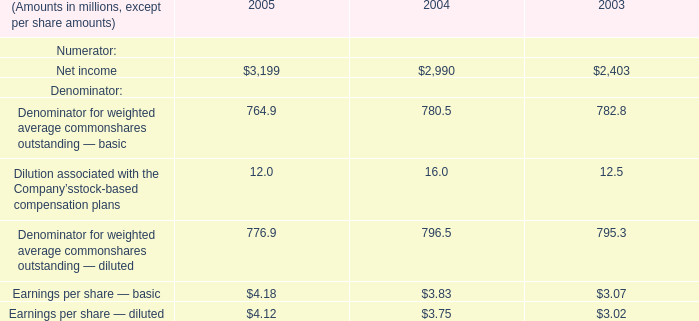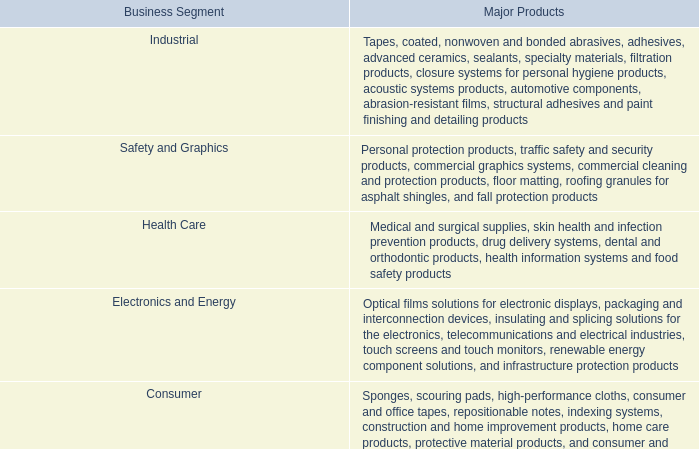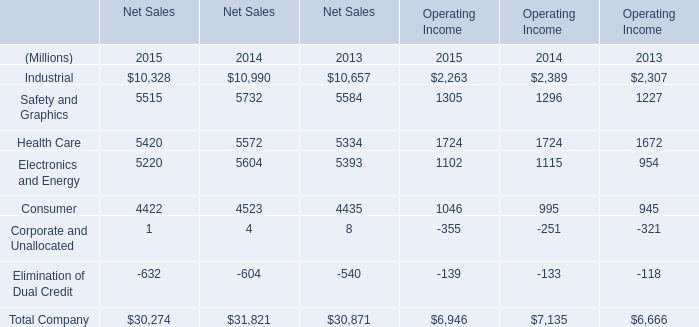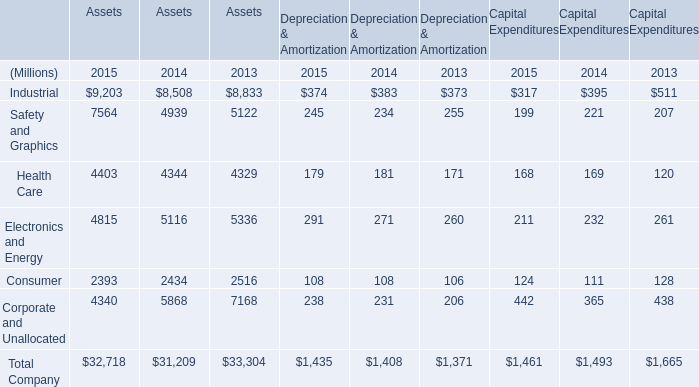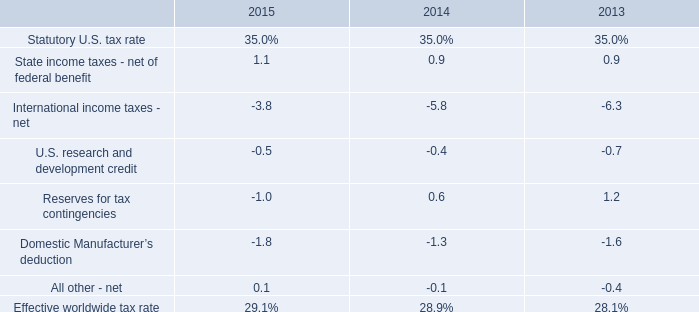What is the sum of Net income of 2005, and Electronics and Energy of Operating Income 2014 ? 
Computations: (3199.0 + 1115.0)
Answer: 4314.0. 